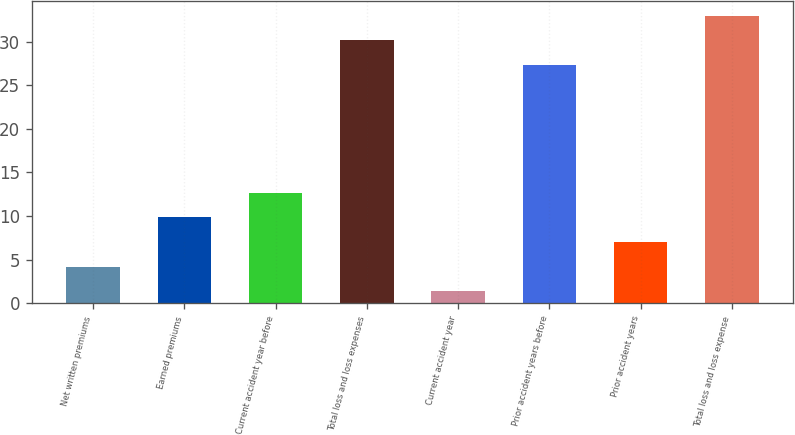<chart> <loc_0><loc_0><loc_500><loc_500><bar_chart><fcel>Net written premiums<fcel>Earned premiums<fcel>Current accident year before<fcel>Total loss and loss expenses<fcel>Current accident year<fcel>Prior accident years before<fcel>Prior accident years<fcel>Total loss and loss expense<nl><fcel>4.2<fcel>9.84<fcel>12.66<fcel>30.12<fcel>1.38<fcel>27.3<fcel>7.02<fcel>32.94<nl></chart> 